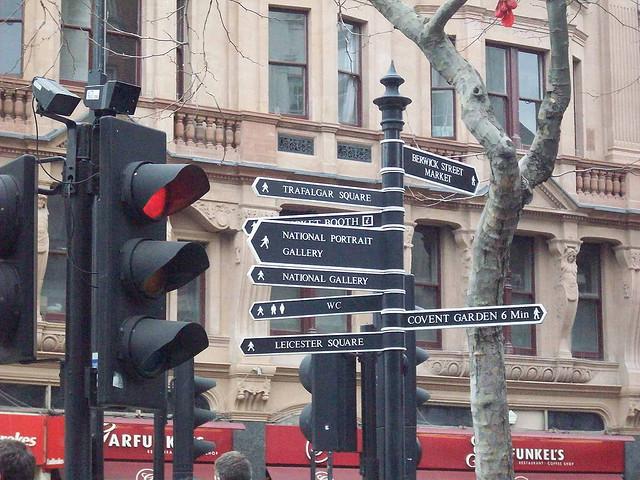What store is that?
Quick response, please. Garfunkel's. Would cars stop or go based on the light?
Be succinct. Stop. How many signs do you see?
Concise answer only. 8. 